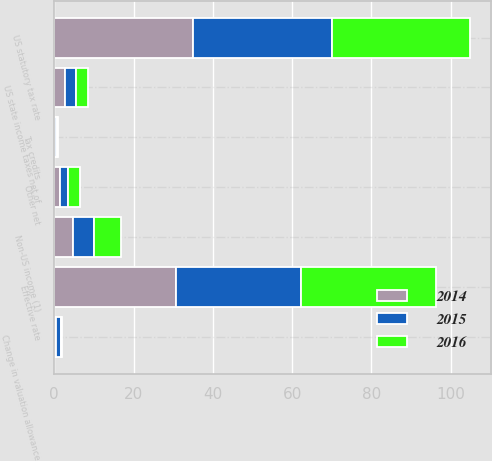Convert chart. <chart><loc_0><loc_0><loc_500><loc_500><stacked_bar_chart><ecel><fcel>US statutory tax rate<fcel>US state income taxes net of<fcel>Non-US income (1)<fcel>Change in valuation allowance<fcel>Tax credits<fcel>Other net<fcel>Effective rate<nl><fcel>2016<fcel>35<fcel>2.9<fcel>6.8<fcel>0.3<fcel>0.4<fcel>3.1<fcel>34.1<nl><fcel>2015<fcel>35<fcel>2.9<fcel>5.2<fcel>1.2<fcel>0.3<fcel>2.1<fcel>31.5<nl><fcel>2014<fcel>35<fcel>2.7<fcel>4.8<fcel>0.4<fcel>0.3<fcel>1.4<fcel>30.8<nl></chart> 